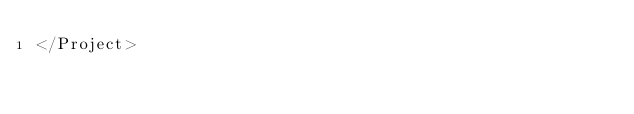<code> <loc_0><loc_0><loc_500><loc_500><_XML_></Project>
</code> 